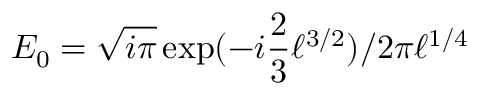Convert formula to latex. <formula><loc_0><loc_0><loc_500><loc_500>E _ { 0 } = \sqrt { i \pi } \exp ( - i \frac { 2 } { 3 } \ell ^ { 3 / 2 } ) / 2 \pi \ell ^ { 1 / 4 }</formula> 